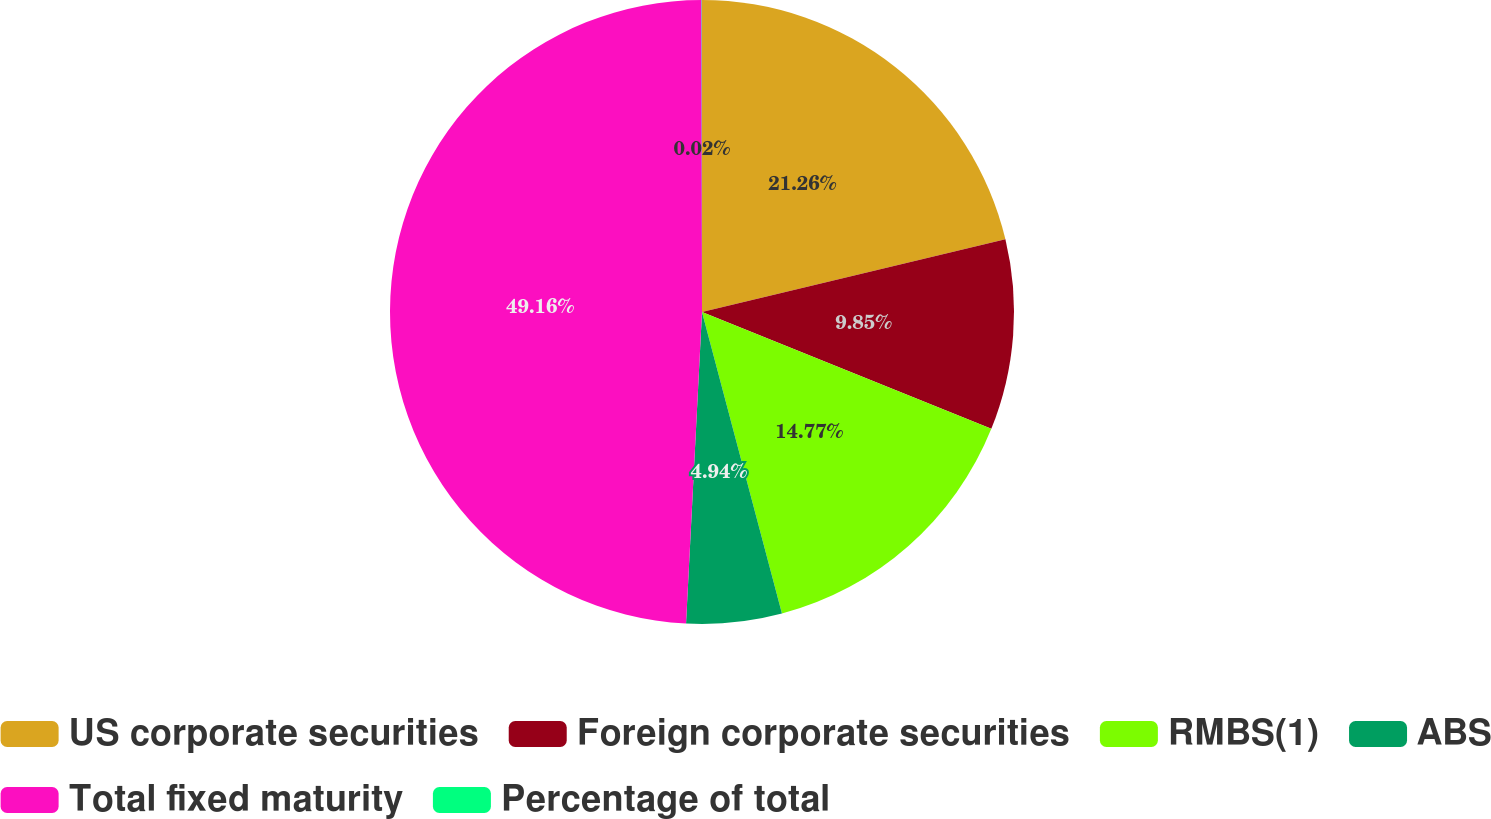Convert chart to OTSL. <chart><loc_0><loc_0><loc_500><loc_500><pie_chart><fcel>US corporate securities<fcel>Foreign corporate securities<fcel>RMBS(1)<fcel>ABS<fcel>Total fixed maturity<fcel>Percentage of total<nl><fcel>21.26%<fcel>9.85%<fcel>14.77%<fcel>4.94%<fcel>49.17%<fcel>0.02%<nl></chart> 